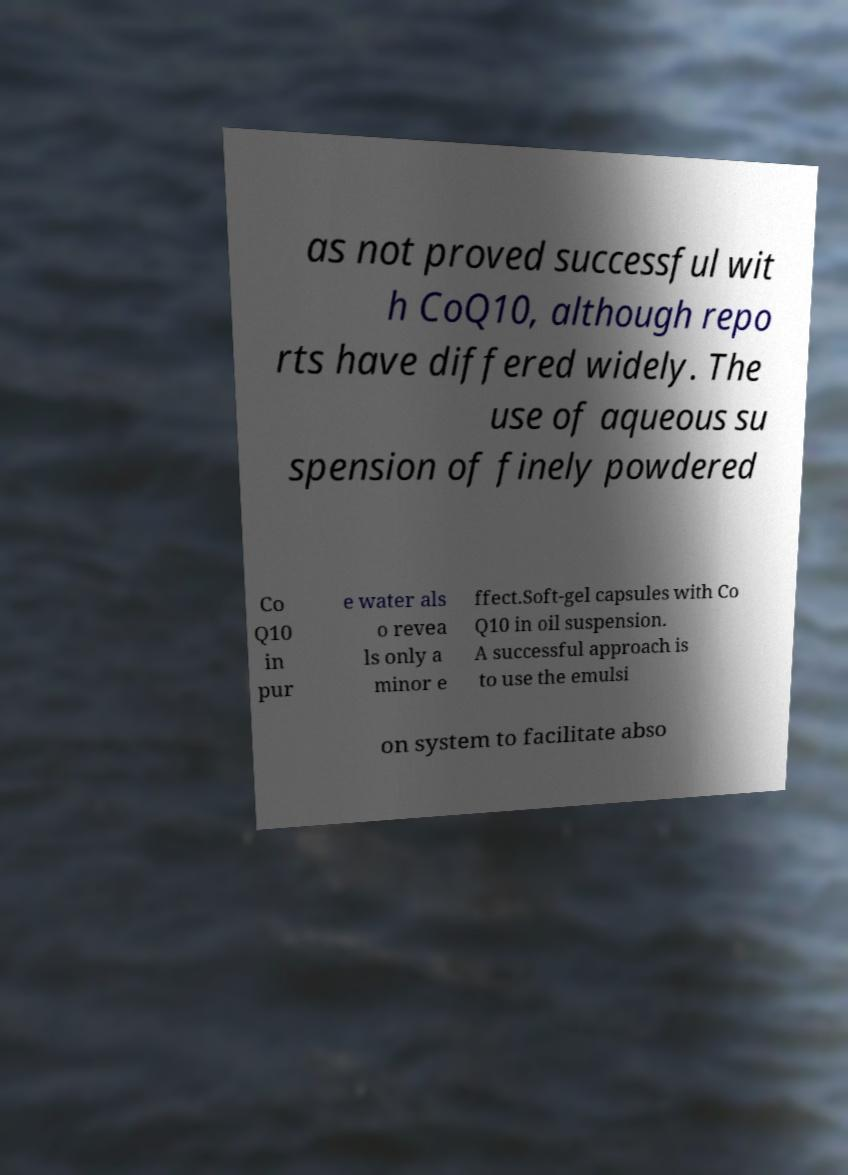For documentation purposes, I need the text within this image transcribed. Could you provide that? as not proved successful wit h CoQ10, although repo rts have differed widely. The use of aqueous su spension of finely powdered Co Q10 in pur e water als o revea ls only a minor e ffect.Soft-gel capsules with Co Q10 in oil suspension. A successful approach is to use the emulsi on system to facilitate abso 